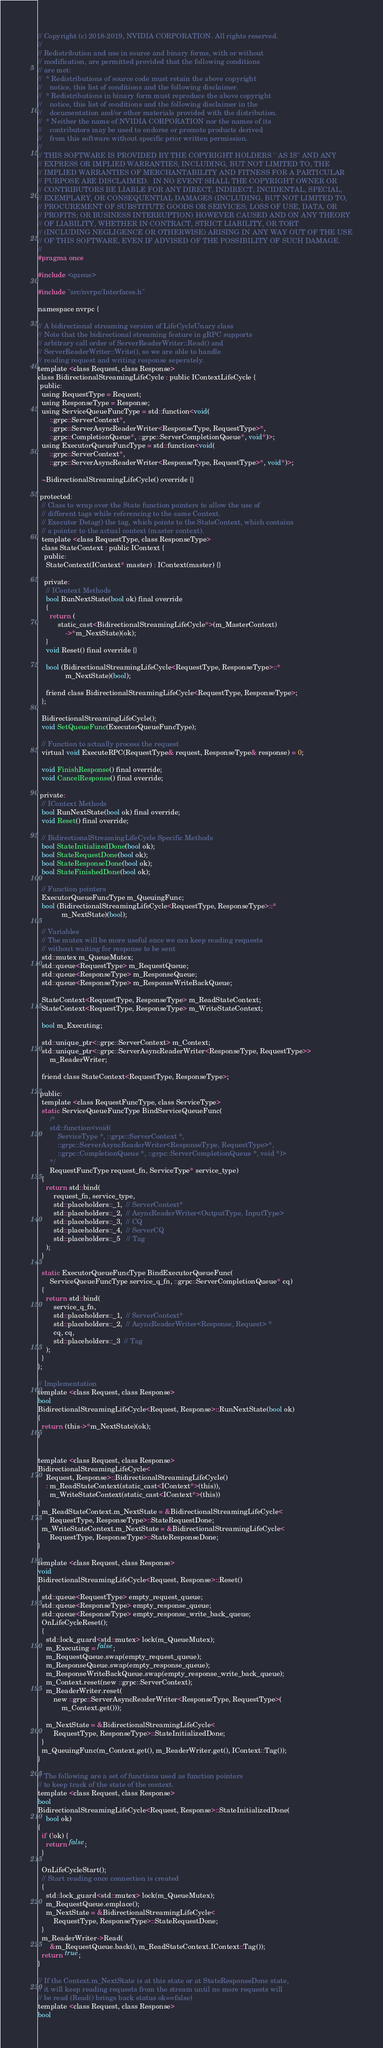Convert code to text. <code><loc_0><loc_0><loc_500><loc_500><_C_>// Copyright (c) 2018-2019, NVIDIA CORPORATION. All rights reserved.
//
// Redistribution and use in source and binary forms, with or without
// modification, are permitted provided that the following conditions
// are met:
//  * Redistributions of source code must retain the above copyright
//    notice, this list of conditions and the following disclaimer.
//  * Redistributions in binary form must reproduce the above copyright
//    notice, this list of conditions and the following disclaimer in the
//    documentation and/or other materials provided with the distribution.
//  * Neither the name of NVIDIA CORPORATION nor the names of its
//    contributors may be used to endorse or promote products derived
//    from this software without specific prior written permission.
//
// THIS SOFTWARE IS PROVIDED BY THE COPYRIGHT HOLDERS ``AS IS'' AND ANY
// EXPRESS OR IMPLIED WARRANTIES, INCLUDING, BUT NOT LIMITED TO, THE
// IMPLIED WARRANTIES OF MERCHANTABILITY AND FITNESS FOR A PARTICULAR
// PURPOSE ARE DISCLAIMED.  IN NO EVENT SHALL THE COPYRIGHT OWNER OR
// CONTRIBUTORS BE LIABLE FOR ANY DIRECT, INDIRECT, INCIDENTAL, SPECIAL,
// EXEMPLARY, OR CONSEQUENTIAL DAMAGES (INCLUDING, BUT NOT LIMITED TO,
// PROCUREMENT OF SUBSTITUTE GOODS OR SERVICES; LOSS OF USE, DATA, OR
// PROFITS; OR BUSINESS INTERRUPTION) HOWEVER CAUSED AND ON ANY THEORY
// OF LIABILITY, WHETHER IN CONTRACT, STRICT LIABILITY, OR TORT
// (INCLUDING NEGLIGENCE OR OTHERWISE) ARISING IN ANY WAY OUT OF THE USE
// OF THIS SOFTWARE, EVEN IF ADVISED OF THE POSSIBILITY OF SUCH DAMAGE.
//
#pragma once

#include <queue>

#include "src/nvrpc/Interfaces.h"

namespace nvrpc {

// A bidirectional streaming version of LifeCycleUnary class
// Note that the bidirectional streaming feature in gRPC supports
// arbitrary call order of ServerReaderWriter::Read() and
// ServerReaderWriter::Write(), so we are able to handle
// reading request and writing response seperately.
template <class Request, class Response>
class BidirectionalStreamingLifeCycle : public IContextLifeCycle {
 public:
  using RequestType = Request;
  using ResponseType = Response;
  using ServiceQueueFuncType = std::function<void(
      ::grpc::ServerContext*,
      ::grpc::ServerAsyncReaderWriter<ResponseType, RequestType>*,
      ::grpc::CompletionQueue*, ::grpc::ServerCompletionQueue*, void*)>;
  using ExecutorQueueFuncType = std::function<void(
      ::grpc::ServerContext*,
      ::grpc::ServerAsyncReaderWriter<ResponseType, RequestType>*, void*)>;

  ~BidirectionalStreamingLifeCycle() override {}

 protected:
  // Class to wrap over the State function pointers to allow the use of
  // different tags while referencing to the same Context.
  // Executor Detag() the tag, which points to the StateContext, which contains
  // a pointer to the actual context (master context).
  template <class RequestType, class ResponseType>
  class StateContext : public IContext {
   public:
    StateContext(IContext* master) : IContext(master) {}

   private:
    // IContext Methods
    bool RunNextState(bool ok) final override
    {
      return (
          static_cast<BidirectionalStreamingLifeCycle*>(m_MasterContext)
              ->*m_NextState)(ok);
    }
    void Reset() final override {}

    bool (BidirectionalStreamingLifeCycle<RequestType, ResponseType>::*
              m_NextState)(bool);

    friend class BidirectionalStreamingLifeCycle<RequestType, ResponseType>;
  };

  BidirectionalStreamingLifeCycle();
  void SetQueueFunc(ExecutorQueueFuncType);

  // Function to actually process the request
  virtual void ExecuteRPC(RequestType& request, ResponseType& response) = 0;

  void FinishResponse() final override;
  void CancelResponse() final override;

 private:
  // IContext Methods
  bool RunNextState(bool ok) final override;
  void Reset() final override;

  // BidirectionalStreamingLifeCycle Specific Methods
  bool StateInitializedDone(bool ok);
  bool StateRequestDone(bool ok);
  bool StateResponseDone(bool ok);
  bool StateFinishedDone(bool ok);

  // Function pointers
  ExecutorQueueFuncType m_QueuingFunc;
  bool (BidirectionalStreamingLifeCycle<RequestType, ResponseType>::*
            m_NextState)(bool);

  // Variables
  // The mutex will be more useful once we can keep reading requests
  // without waiting for response to be sent
  std::mutex m_QueueMutex;
  std::queue<RequestType> m_RequestQueue;
  std::queue<ResponseType> m_ResponseQueue;
  std::queue<ResponseType> m_ResponseWriteBackQueue;

  StateContext<RequestType, ResponseType> m_ReadStateContext;
  StateContext<RequestType, ResponseType> m_WriteStateContext;

  bool m_Executing;

  std::unique_ptr<::grpc::ServerContext> m_Context;
  std::unique_ptr<::grpc::ServerAsyncReaderWriter<ResponseType, RequestType>>
      m_ReaderWriter;

  friend class StateContext<RequestType, ResponseType>;

 public:
  template <class RequestFuncType, class ServiceType>
  static ServiceQueueFuncType BindServiceQueueFunc(
      /*
      std::function<void(
          ServiceType *, ::grpc::ServerContext *,
          ::grpc::ServerAsyncReaderWriter<ResponseType, RequestType>*,
          ::grpc::CompletionQueue *, ::grpc::ServerCompletionQueue *, void *)>
      */
      RequestFuncType request_fn, ServiceType* service_type)
  {
    return std::bind(
        request_fn, service_type,
        std::placeholders::_1,  // ServerContext*
        std::placeholders::_2,  // AsyncReaderWriter<OutputType, InputType>
        std::placeholders::_3,  // CQ
        std::placeholders::_4,  // ServerCQ
        std::placeholders::_5   // Tag
    );
  }

  static ExecutorQueueFuncType BindExecutorQueueFunc(
      ServiceQueueFuncType service_q_fn, ::grpc::ServerCompletionQueue* cq)
  {
    return std::bind(
        service_q_fn,
        std::placeholders::_1,  // ServerContext*
        std::placeholders::_2,  // AsyncReaderWriter<Response, Request> *
        cq, cq,
        std::placeholders::_3  // Tag
    );
  }
};

// Implementation
template <class Request, class Response>
bool
BidirectionalStreamingLifeCycle<Request, Response>::RunNextState(bool ok)
{
  return (this->*m_NextState)(ok);
}


template <class Request, class Response>
BidirectionalStreamingLifeCycle<
    Request, Response>::BidirectionalStreamingLifeCycle()
    : m_ReadStateContext(static_cast<IContext*>(this)),
      m_WriteStateContext(static_cast<IContext*>(this))
{
  m_ReadStateContext.m_NextState = &BidirectionalStreamingLifeCycle<
      RequestType, ResponseType>::StateRequestDone;
  m_WriteStateContext.m_NextState = &BidirectionalStreamingLifeCycle<
      RequestType, ResponseType>::StateResponseDone;
}

template <class Request, class Response>
void
BidirectionalStreamingLifeCycle<Request, Response>::Reset()
{
  std::queue<RequestType> empty_request_queue;
  std::queue<ResponseType> empty_response_queue;
  std::queue<ResponseType> empty_response_write_back_queue;
  OnLifeCycleReset();
  {
    std::lock_guard<std::mutex> lock(m_QueueMutex);
    m_Executing = false;
    m_RequestQueue.swap(empty_request_queue);
    m_ResponseQueue.swap(empty_response_queue);
    m_ResponseWriteBackQueue.swap(empty_response_write_back_queue);
    m_Context.reset(new ::grpc::ServerContext);
    m_ReaderWriter.reset(
        new ::grpc::ServerAsyncReaderWriter<ResponseType, RequestType>(
            m_Context.get()));

    m_NextState = &BidirectionalStreamingLifeCycle<
        RequestType, ResponseType>::StateInitializedDone;
  }
  m_QueuingFunc(m_Context.get(), m_ReaderWriter.get(), IContext::Tag());
}

// The following are a set of functions used as function pointers
// to keep track of the state of the context.
template <class Request, class Response>
bool
BidirectionalStreamingLifeCycle<Request, Response>::StateInitializedDone(
    bool ok)
{
  if (!ok) {
    return false;
  }

  OnLifeCycleStart();
  // Start reading once connection is created
  {
    std::lock_guard<std::mutex> lock(m_QueueMutex);
    m_RequestQueue.emplace();
    m_NextState = &BidirectionalStreamingLifeCycle<
        RequestType, ResponseType>::StateRequestDone;
  }
  m_ReaderWriter->Read(
      &m_RequestQueue.back(), m_ReadStateContext.IContext::Tag());
  return true;
}

// If the Context.m_NextState is at this state or at StateResponseDone state,
// it will keep reading requests from the stream until no more requests will
// be read (Read() brings back status ok==false)
template <class Request, class Response>
bool</code> 